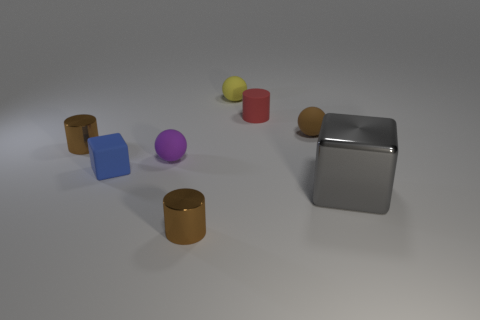Add 1 small brown rubber things. How many objects exist? 9 Subtract all cylinders. How many objects are left? 5 Add 4 blue matte blocks. How many blue matte blocks are left? 5 Add 6 brown cylinders. How many brown cylinders exist? 8 Subtract 1 red cylinders. How many objects are left? 7 Subtract all tiny rubber spheres. Subtract all small purple matte objects. How many objects are left? 4 